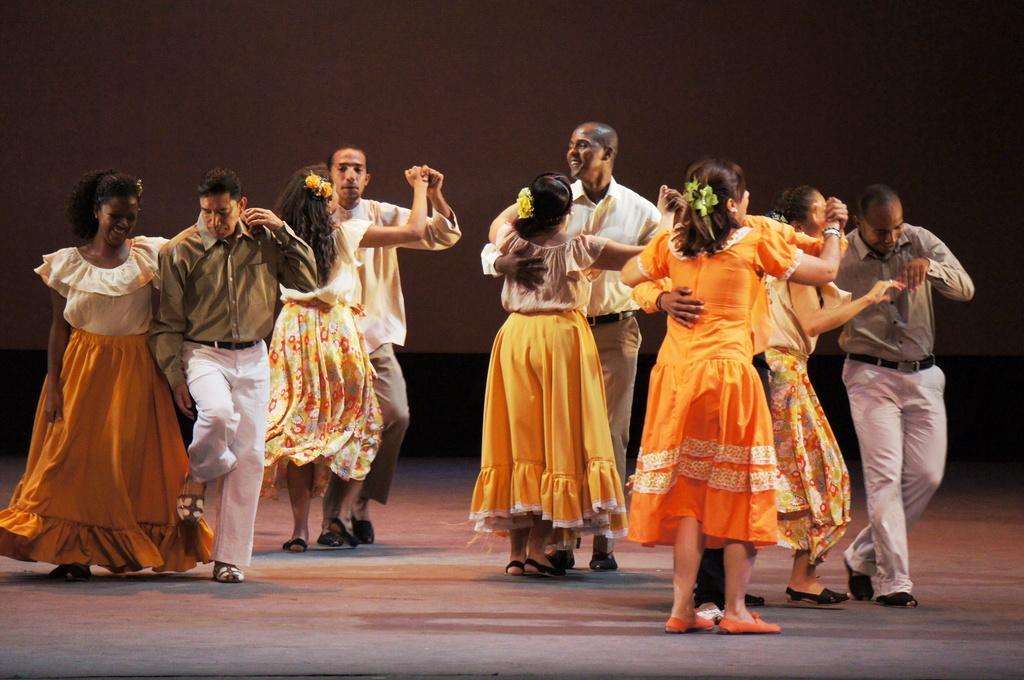Please provide a concise description of this image. In this image, we can see some couples dancing on the floor, in the background, we can see a wall. 